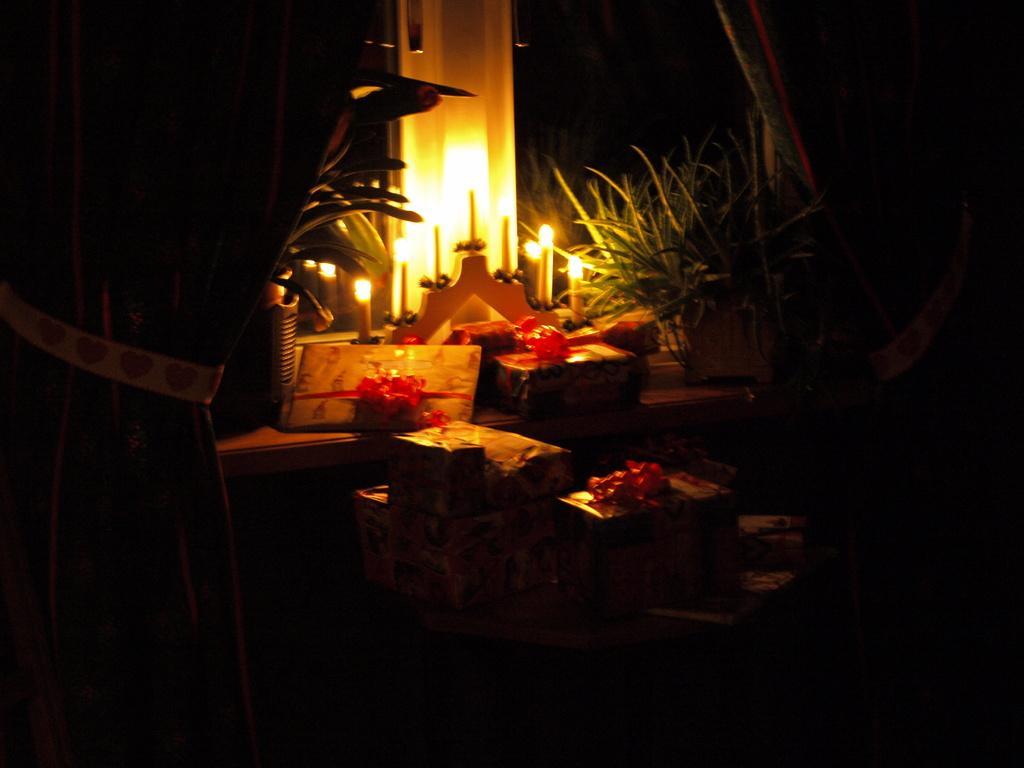Could you give a brief overview of what you see in this image? In the foreground of this picture we can see the curtains. In the center we can see there are many number of gift packs and we can see a potted plant and the candle stand and we can see the burning candles and some other objects. 